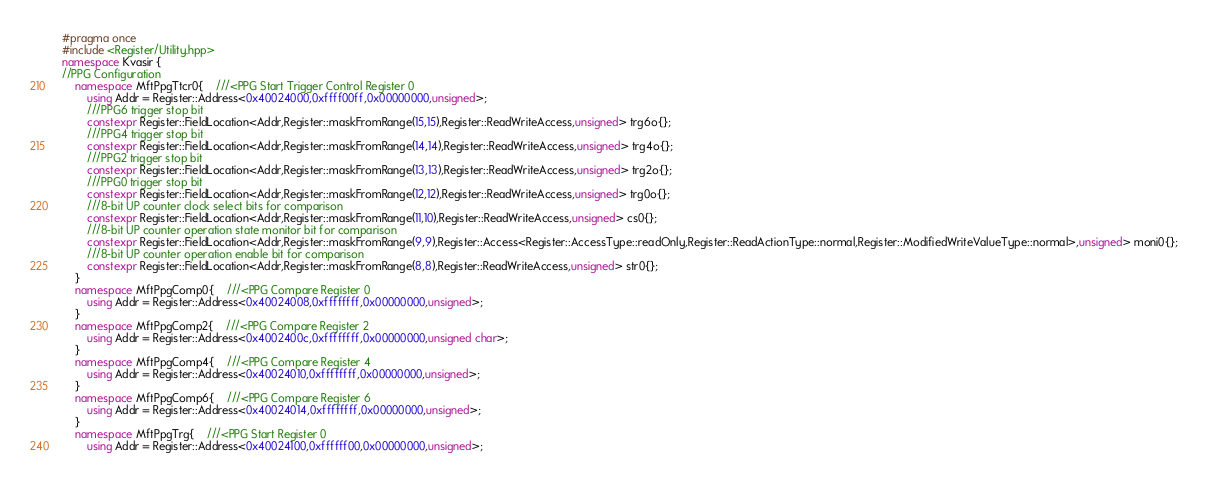Convert code to text. <code><loc_0><loc_0><loc_500><loc_500><_C++_>#pragma once 
#include <Register/Utility.hpp>
namespace Kvasir {
//PPG Configuration
    namespace MftPpgTtcr0{    ///<PPG Start Trigger Control Register 0
        using Addr = Register::Address<0x40024000,0xffff00ff,0x00000000,unsigned>;
        ///PPG6 trigger stop bit
        constexpr Register::FieldLocation<Addr,Register::maskFromRange(15,15),Register::ReadWriteAccess,unsigned> trg6o{}; 
        ///PPG4 trigger stop bit
        constexpr Register::FieldLocation<Addr,Register::maskFromRange(14,14),Register::ReadWriteAccess,unsigned> trg4o{}; 
        ///PPG2 trigger stop bit
        constexpr Register::FieldLocation<Addr,Register::maskFromRange(13,13),Register::ReadWriteAccess,unsigned> trg2o{}; 
        ///PPG0 trigger stop bit
        constexpr Register::FieldLocation<Addr,Register::maskFromRange(12,12),Register::ReadWriteAccess,unsigned> trg0o{}; 
        ///8-bit UP counter clock select bits for comparison
        constexpr Register::FieldLocation<Addr,Register::maskFromRange(11,10),Register::ReadWriteAccess,unsigned> cs0{}; 
        ///8-bit UP counter operation state monitor bit for comparison
        constexpr Register::FieldLocation<Addr,Register::maskFromRange(9,9),Register::Access<Register::AccessType::readOnly,Register::ReadActionType::normal,Register::ModifiedWriteValueType::normal>,unsigned> moni0{}; 
        ///8-bit UP counter operation enable bit for comparison
        constexpr Register::FieldLocation<Addr,Register::maskFromRange(8,8),Register::ReadWriteAccess,unsigned> str0{}; 
    }
    namespace MftPpgComp0{    ///<PPG Compare Register 0
        using Addr = Register::Address<0x40024008,0xffffffff,0x00000000,unsigned>;
    }
    namespace MftPpgComp2{    ///<PPG Compare Register 2
        using Addr = Register::Address<0x4002400c,0xffffffff,0x00000000,unsigned char>;
    }
    namespace MftPpgComp4{    ///<PPG Compare Register 4
        using Addr = Register::Address<0x40024010,0xffffffff,0x00000000,unsigned>;
    }
    namespace MftPpgComp6{    ///<PPG Compare Register 6
        using Addr = Register::Address<0x40024014,0xffffffff,0x00000000,unsigned>;
    }
    namespace MftPpgTrg{    ///<PPG Start Register 0
        using Addr = Register::Address<0x40024100,0xffffff00,0x00000000,unsigned>;</code> 